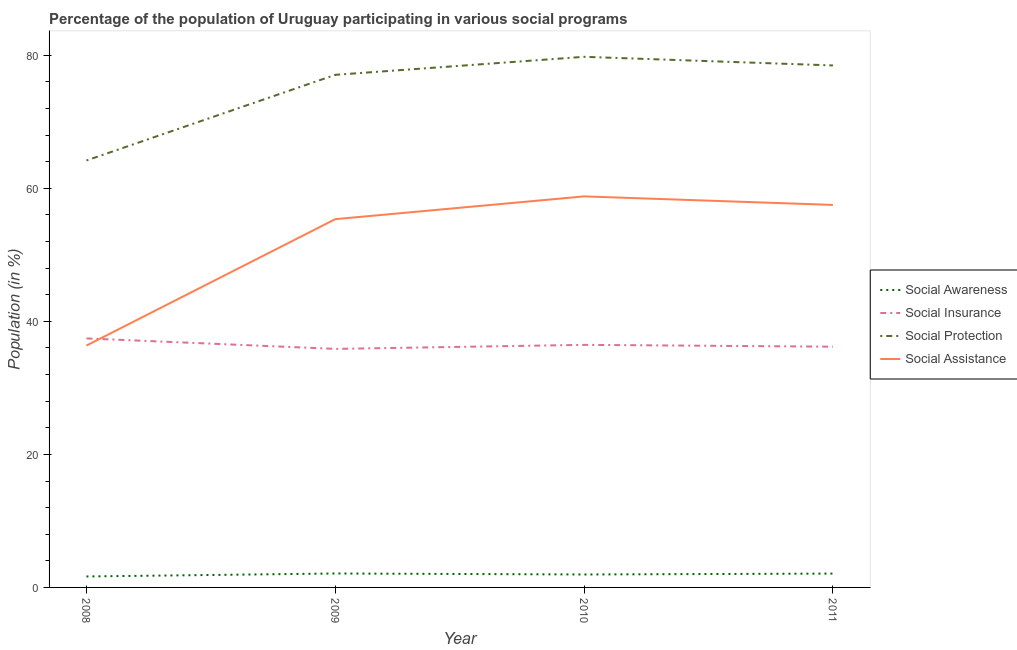What is the participation of population in social awareness programs in 2010?
Your answer should be very brief. 1.95. Across all years, what is the maximum participation of population in social assistance programs?
Make the answer very short. 58.79. Across all years, what is the minimum participation of population in social insurance programs?
Your answer should be very brief. 35.86. In which year was the participation of population in social protection programs maximum?
Your answer should be very brief. 2010. In which year was the participation of population in social insurance programs minimum?
Provide a succinct answer. 2009. What is the total participation of population in social insurance programs in the graph?
Offer a very short reply. 145.96. What is the difference between the participation of population in social awareness programs in 2009 and that in 2010?
Provide a succinct answer. 0.15. What is the difference between the participation of population in social insurance programs in 2009 and the participation of population in social awareness programs in 2010?
Provide a succinct answer. 33.92. What is the average participation of population in social awareness programs per year?
Offer a terse response. 1.94. In the year 2009, what is the difference between the participation of population in social insurance programs and participation of population in social assistance programs?
Keep it short and to the point. -19.5. In how many years, is the participation of population in social protection programs greater than 36 %?
Offer a terse response. 4. What is the ratio of the participation of population in social protection programs in 2009 to that in 2011?
Keep it short and to the point. 0.98. Is the participation of population in social awareness programs in 2009 less than that in 2011?
Your response must be concise. No. Is the difference between the participation of population in social awareness programs in 2009 and 2011 greater than the difference between the participation of population in social protection programs in 2009 and 2011?
Ensure brevity in your answer.  Yes. What is the difference between the highest and the second highest participation of population in social awareness programs?
Offer a very short reply. 0.01. What is the difference between the highest and the lowest participation of population in social assistance programs?
Provide a succinct answer. 22.43. How many lines are there?
Your answer should be compact. 4. How many years are there in the graph?
Keep it short and to the point. 4. Where does the legend appear in the graph?
Your answer should be very brief. Center right. How many legend labels are there?
Your response must be concise. 4. How are the legend labels stacked?
Keep it short and to the point. Vertical. What is the title of the graph?
Give a very brief answer. Percentage of the population of Uruguay participating in various social programs . Does "Forest" appear as one of the legend labels in the graph?
Your answer should be compact. No. What is the label or title of the X-axis?
Keep it short and to the point. Year. What is the Population (in %) of Social Awareness in 2008?
Your response must be concise. 1.65. What is the Population (in %) of Social Insurance in 2008?
Make the answer very short. 37.44. What is the Population (in %) of Social Protection in 2008?
Offer a very short reply. 64.19. What is the Population (in %) in Social Assistance in 2008?
Provide a short and direct response. 36.36. What is the Population (in %) of Social Awareness in 2009?
Keep it short and to the point. 2.1. What is the Population (in %) in Social Insurance in 2009?
Your answer should be very brief. 35.86. What is the Population (in %) of Social Protection in 2009?
Keep it short and to the point. 77.07. What is the Population (in %) in Social Assistance in 2009?
Provide a succinct answer. 55.37. What is the Population (in %) in Social Awareness in 2010?
Give a very brief answer. 1.95. What is the Population (in %) in Social Insurance in 2010?
Make the answer very short. 36.47. What is the Population (in %) of Social Protection in 2010?
Your answer should be compact. 79.78. What is the Population (in %) in Social Assistance in 2010?
Keep it short and to the point. 58.79. What is the Population (in %) in Social Awareness in 2011?
Your response must be concise. 2.08. What is the Population (in %) of Social Insurance in 2011?
Provide a succinct answer. 36.19. What is the Population (in %) in Social Protection in 2011?
Make the answer very short. 78.48. What is the Population (in %) of Social Assistance in 2011?
Keep it short and to the point. 57.51. Across all years, what is the maximum Population (in %) in Social Awareness?
Your response must be concise. 2.1. Across all years, what is the maximum Population (in %) in Social Insurance?
Your answer should be very brief. 37.44. Across all years, what is the maximum Population (in %) in Social Protection?
Your response must be concise. 79.78. Across all years, what is the maximum Population (in %) of Social Assistance?
Provide a short and direct response. 58.79. Across all years, what is the minimum Population (in %) in Social Awareness?
Your answer should be very brief. 1.65. Across all years, what is the minimum Population (in %) of Social Insurance?
Your response must be concise. 35.86. Across all years, what is the minimum Population (in %) in Social Protection?
Your answer should be compact. 64.19. Across all years, what is the minimum Population (in %) of Social Assistance?
Provide a succinct answer. 36.36. What is the total Population (in %) of Social Awareness in the graph?
Provide a short and direct response. 7.77. What is the total Population (in %) of Social Insurance in the graph?
Give a very brief answer. 145.96. What is the total Population (in %) of Social Protection in the graph?
Your answer should be compact. 299.51. What is the total Population (in %) of Social Assistance in the graph?
Your answer should be compact. 208.03. What is the difference between the Population (in %) in Social Awareness in 2008 and that in 2009?
Offer a terse response. -0.45. What is the difference between the Population (in %) of Social Insurance in 2008 and that in 2009?
Offer a very short reply. 1.57. What is the difference between the Population (in %) of Social Protection in 2008 and that in 2009?
Ensure brevity in your answer.  -12.88. What is the difference between the Population (in %) of Social Assistance in 2008 and that in 2009?
Ensure brevity in your answer.  -19.01. What is the difference between the Population (in %) of Social Awareness in 2008 and that in 2010?
Offer a terse response. -0.3. What is the difference between the Population (in %) of Social Insurance in 2008 and that in 2010?
Your answer should be very brief. 0.97. What is the difference between the Population (in %) in Social Protection in 2008 and that in 2010?
Make the answer very short. -15.59. What is the difference between the Population (in %) in Social Assistance in 2008 and that in 2010?
Ensure brevity in your answer.  -22.43. What is the difference between the Population (in %) of Social Awareness in 2008 and that in 2011?
Offer a very short reply. -0.43. What is the difference between the Population (in %) of Social Insurance in 2008 and that in 2011?
Provide a short and direct response. 1.24. What is the difference between the Population (in %) in Social Protection in 2008 and that in 2011?
Your answer should be compact. -14.29. What is the difference between the Population (in %) in Social Assistance in 2008 and that in 2011?
Give a very brief answer. -21.15. What is the difference between the Population (in %) in Social Awareness in 2009 and that in 2010?
Provide a succinct answer. 0.15. What is the difference between the Population (in %) in Social Insurance in 2009 and that in 2010?
Your answer should be compact. -0.6. What is the difference between the Population (in %) in Social Protection in 2009 and that in 2010?
Ensure brevity in your answer.  -2.71. What is the difference between the Population (in %) of Social Assistance in 2009 and that in 2010?
Make the answer very short. -3.42. What is the difference between the Population (in %) in Social Awareness in 2009 and that in 2011?
Give a very brief answer. 0.01. What is the difference between the Population (in %) in Social Insurance in 2009 and that in 2011?
Provide a succinct answer. -0.33. What is the difference between the Population (in %) in Social Protection in 2009 and that in 2011?
Offer a terse response. -1.41. What is the difference between the Population (in %) in Social Assistance in 2009 and that in 2011?
Your answer should be compact. -2.14. What is the difference between the Population (in %) in Social Awareness in 2010 and that in 2011?
Provide a succinct answer. -0.14. What is the difference between the Population (in %) of Social Insurance in 2010 and that in 2011?
Provide a succinct answer. 0.27. What is the difference between the Population (in %) in Social Protection in 2010 and that in 2011?
Ensure brevity in your answer.  1.3. What is the difference between the Population (in %) in Social Assistance in 2010 and that in 2011?
Give a very brief answer. 1.28. What is the difference between the Population (in %) of Social Awareness in 2008 and the Population (in %) of Social Insurance in 2009?
Provide a short and direct response. -34.22. What is the difference between the Population (in %) in Social Awareness in 2008 and the Population (in %) in Social Protection in 2009?
Your answer should be compact. -75.42. What is the difference between the Population (in %) in Social Awareness in 2008 and the Population (in %) in Social Assistance in 2009?
Ensure brevity in your answer.  -53.72. What is the difference between the Population (in %) of Social Insurance in 2008 and the Population (in %) of Social Protection in 2009?
Provide a short and direct response. -39.63. What is the difference between the Population (in %) of Social Insurance in 2008 and the Population (in %) of Social Assistance in 2009?
Make the answer very short. -17.93. What is the difference between the Population (in %) of Social Protection in 2008 and the Population (in %) of Social Assistance in 2009?
Offer a very short reply. 8.82. What is the difference between the Population (in %) of Social Awareness in 2008 and the Population (in %) of Social Insurance in 2010?
Your response must be concise. -34.82. What is the difference between the Population (in %) of Social Awareness in 2008 and the Population (in %) of Social Protection in 2010?
Provide a succinct answer. -78.13. What is the difference between the Population (in %) in Social Awareness in 2008 and the Population (in %) in Social Assistance in 2010?
Keep it short and to the point. -57.14. What is the difference between the Population (in %) in Social Insurance in 2008 and the Population (in %) in Social Protection in 2010?
Your answer should be compact. -42.34. What is the difference between the Population (in %) in Social Insurance in 2008 and the Population (in %) in Social Assistance in 2010?
Offer a very short reply. -21.35. What is the difference between the Population (in %) in Social Protection in 2008 and the Population (in %) in Social Assistance in 2010?
Give a very brief answer. 5.4. What is the difference between the Population (in %) of Social Awareness in 2008 and the Population (in %) of Social Insurance in 2011?
Your response must be concise. -34.55. What is the difference between the Population (in %) in Social Awareness in 2008 and the Population (in %) in Social Protection in 2011?
Ensure brevity in your answer.  -76.83. What is the difference between the Population (in %) in Social Awareness in 2008 and the Population (in %) in Social Assistance in 2011?
Your answer should be compact. -55.86. What is the difference between the Population (in %) of Social Insurance in 2008 and the Population (in %) of Social Protection in 2011?
Offer a terse response. -41.04. What is the difference between the Population (in %) of Social Insurance in 2008 and the Population (in %) of Social Assistance in 2011?
Give a very brief answer. -20.07. What is the difference between the Population (in %) of Social Protection in 2008 and the Population (in %) of Social Assistance in 2011?
Your response must be concise. 6.68. What is the difference between the Population (in %) in Social Awareness in 2009 and the Population (in %) in Social Insurance in 2010?
Your answer should be compact. -34.37. What is the difference between the Population (in %) of Social Awareness in 2009 and the Population (in %) of Social Protection in 2010?
Your answer should be very brief. -77.68. What is the difference between the Population (in %) in Social Awareness in 2009 and the Population (in %) in Social Assistance in 2010?
Provide a short and direct response. -56.7. What is the difference between the Population (in %) in Social Insurance in 2009 and the Population (in %) in Social Protection in 2010?
Give a very brief answer. -43.91. What is the difference between the Population (in %) in Social Insurance in 2009 and the Population (in %) in Social Assistance in 2010?
Your answer should be compact. -22.93. What is the difference between the Population (in %) of Social Protection in 2009 and the Population (in %) of Social Assistance in 2010?
Ensure brevity in your answer.  18.27. What is the difference between the Population (in %) of Social Awareness in 2009 and the Population (in %) of Social Insurance in 2011?
Your response must be concise. -34.1. What is the difference between the Population (in %) of Social Awareness in 2009 and the Population (in %) of Social Protection in 2011?
Provide a succinct answer. -76.38. What is the difference between the Population (in %) of Social Awareness in 2009 and the Population (in %) of Social Assistance in 2011?
Offer a terse response. -55.41. What is the difference between the Population (in %) of Social Insurance in 2009 and the Population (in %) of Social Protection in 2011?
Provide a succinct answer. -42.61. What is the difference between the Population (in %) in Social Insurance in 2009 and the Population (in %) in Social Assistance in 2011?
Make the answer very short. -21.64. What is the difference between the Population (in %) of Social Protection in 2009 and the Population (in %) of Social Assistance in 2011?
Keep it short and to the point. 19.56. What is the difference between the Population (in %) in Social Awareness in 2010 and the Population (in %) in Social Insurance in 2011?
Provide a succinct answer. -34.25. What is the difference between the Population (in %) of Social Awareness in 2010 and the Population (in %) of Social Protection in 2011?
Your answer should be very brief. -76.53. What is the difference between the Population (in %) in Social Awareness in 2010 and the Population (in %) in Social Assistance in 2011?
Ensure brevity in your answer.  -55.56. What is the difference between the Population (in %) in Social Insurance in 2010 and the Population (in %) in Social Protection in 2011?
Give a very brief answer. -42.01. What is the difference between the Population (in %) of Social Insurance in 2010 and the Population (in %) of Social Assistance in 2011?
Keep it short and to the point. -21.04. What is the difference between the Population (in %) of Social Protection in 2010 and the Population (in %) of Social Assistance in 2011?
Ensure brevity in your answer.  22.27. What is the average Population (in %) of Social Awareness per year?
Make the answer very short. 1.94. What is the average Population (in %) in Social Insurance per year?
Give a very brief answer. 36.49. What is the average Population (in %) of Social Protection per year?
Your answer should be very brief. 74.88. What is the average Population (in %) in Social Assistance per year?
Provide a short and direct response. 52.01. In the year 2008, what is the difference between the Population (in %) of Social Awareness and Population (in %) of Social Insurance?
Your response must be concise. -35.79. In the year 2008, what is the difference between the Population (in %) of Social Awareness and Population (in %) of Social Protection?
Provide a succinct answer. -62.54. In the year 2008, what is the difference between the Population (in %) in Social Awareness and Population (in %) in Social Assistance?
Ensure brevity in your answer.  -34.71. In the year 2008, what is the difference between the Population (in %) in Social Insurance and Population (in %) in Social Protection?
Offer a very short reply. -26.75. In the year 2008, what is the difference between the Population (in %) of Social Insurance and Population (in %) of Social Assistance?
Your answer should be compact. 1.08. In the year 2008, what is the difference between the Population (in %) of Social Protection and Population (in %) of Social Assistance?
Offer a terse response. 27.83. In the year 2009, what is the difference between the Population (in %) of Social Awareness and Population (in %) of Social Insurance?
Offer a very short reply. -33.77. In the year 2009, what is the difference between the Population (in %) in Social Awareness and Population (in %) in Social Protection?
Give a very brief answer. -74.97. In the year 2009, what is the difference between the Population (in %) of Social Awareness and Population (in %) of Social Assistance?
Your answer should be very brief. -53.27. In the year 2009, what is the difference between the Population (in %) in Social Insurance and Population (in %) in Social Protection?
Offer a terse response. -41.2. In the year 2009, what is the difference between the Population (in %) in Social Insurance and Population (in %) in Social Assistance?
Provide a short and direct response. -19.5. In the year 2009, what is the difference between the Population (in %) in Social Protection and Population (in %) in Social Assistance?
Offer a terse response. 21.7. In the year 2010, what is the difference between the Population (in %) in Social Awareness and Population (in %) in Social Insurance?
Your answer should be very brief. -34.52. In the year 2010, what is the difference between the Population (in %) in Social Awareness and Population (in %) in Social Protection?
Offer a very short reply. -77.83. In the year 2010, what is the difference between the Population (in %) of Social Awareness and Population (in %) of Social Assistance?
Give a very brief answer. -56.85. In the year 2010, what is the difference between the Population (in %) of Social Insurance and Population (in %) of Social Protection?
Your answer should be compact. -43.31. In the year 2010, what is the difference between the Population (in %) in Social Insurance and Population (in %) in Social Assistance?
Keep it short and to the point. -22.32. In the year 2010, what is the difference between the Population (in %) of Social Protection and Population (in %) of Social Assistance?
Your response must be concise. 20.98. In the year 2011, what is the difference between the Population (in %) in Social Awareness and Population (in %) in Social Insurance?
Provide a succinct answer. -34.11. In the year 2011, what is the difference between the Population (in %) in Social Awareness and Population (in %) in Social Protection?
Your answer should be compact. -76.4. In the year 2011, what is the difference between the Population (in %) in Social Awareness and Population (in %) in Social Assistance?
Your response must be concise. -55.43. In the year 2011, what is the difference between the Population (in %) in Social Insurance and Population (in %) in Social Protection?
Offer a terse response. -42.28. In the year 2011, what is the difference between the Population (in %) of Social Insurance and Population (in %) of Social Assistance?
Make the answer very short. -21.31. In the year 2011, what is the difference between the Population (in %) of Social Protection and Population (in %) of Social Assistance?
Your answer should be very brief. 20.97. What is the ratio of the Population (in %) of Social Awareness in 2008 to that in 2009?
Offer a very short reply. 0.79. What is the ratio of the Population (in %) of Social Insurance in 2008 to that in 2009?
Offer a terse response. 1.04. What is the ratio of the Population (in %) in Social Protection in 2008 to that in 2009?
Your answer should be compact. 0.83. What is the ratio of the Population (in %) in Social Assistance in 2008 to that in 2009?
Give a very brief answer. 0.66. What is the ratio of the Population (in %) of Social Awareness in 2008 to that in 2010?
Give a very brief answer. 0.85. What is the ratio of the Population (in %) in Social Insurance in 2008 to that in 2010?
Keep it short and to the point. 1.03. What is the ratio of the Population (in %) in Social Protection in 2008 to that in 2010?
Offer a terse response. 0.8. What is the ratio of the Population (in %) of Social Assistance in 2008 to that in 2010?
Give a very brief answer. 0.62. What is the ratio of the Population (in %) of Social Awareness in 2008 to that in 2011?
Keep it short and to the point. 0.79. What is the ratio of the Population (in %) of Social Insurance in 2008 to that in 2011?
Offer a very short reply. 1.03. What is the ratio of the Population (in %) in Social Protection in 2008 to that in 2011?
Keep it short and to the point. 0.82. What is the ratio of the Population (in %) of Social Assistance in 2008 to that in 2011?
Provide a succinct answer. 0.63. What is the ratio of the Population (in %) of Social Awareness in 2009 to that in 2010?
Offer a very short reply. 1.08. What is the ratio of the Population (in %) in Social Insurance in 2009 to that in 2010?
Ensure brevity in your answer.  0.98. What is the ratio of the Population (in %) of Social Assistance in 2009 to that in 2010?
Provide a succinct answer. 0.94. What is the ratio of the Population (in %) of Social Awareness in 2009 to that in 2011?
Provide a succinct answer. 1.01. What is the ratio of the Population (in %) in Social Insurance in 2009 to that in 2011?
Give a very brief answer. 0.99. What is the ratio of the Population (in %) of Social Protection in 2009 to that in 2011?
Your answer should be compact. 0.98. What is the ratio of the Population (in %) of Social Assistance in 2009 to that in 2011?
Provide a short and direct response. 0.96. What is the ratio of the Population (in %) in Social Awareness in 2010 to that in 2011?
Your response must be concise. 0.94. What is the ratio of the Population (in %) in Social Insurance in 2010 to that in 2011?
Offer a terse response. 1.01. What is the ratio of the Population (in %) of Social Protection in 2010 to that in 2011?
Offer a terse response. 1.02. What is the ratio of the Population (in %) in Social Assistance in 2010 to that in 2011?
Offer a terse response. 1.02. What is the difference between the highest and the second highest Population (in %) of Social Awareness?
Your answer should be compact. 0.01. What is the difference between the highest and the second highest Population (in %) of Social Insurance?
Provide a short and direct response. 0.97. What is the difference between the highest and the second highest Population (in %) in Social Protection?
Provide a short and direct response. 1.3. What is the difference between the highest and the second highest Population (in %) of Social Assistance?
Offer a terse response. 1.28. What is the difference between the highest and the lowest Population (in %) in Social Awareness?
Give a very brief answer. 0.45. What is the difference between the highest and the lowest Population (in %) of Social Insurance?
Your answer should be compact. 1.57. What is the difference between the highest and the lowest Population (in %) in Social Protection?
Offer a very short reply. 15.59. What is the difference between the highest and the lowest Population (in %) in Social Assistance?
Your answer should be very brief. 22.43. 